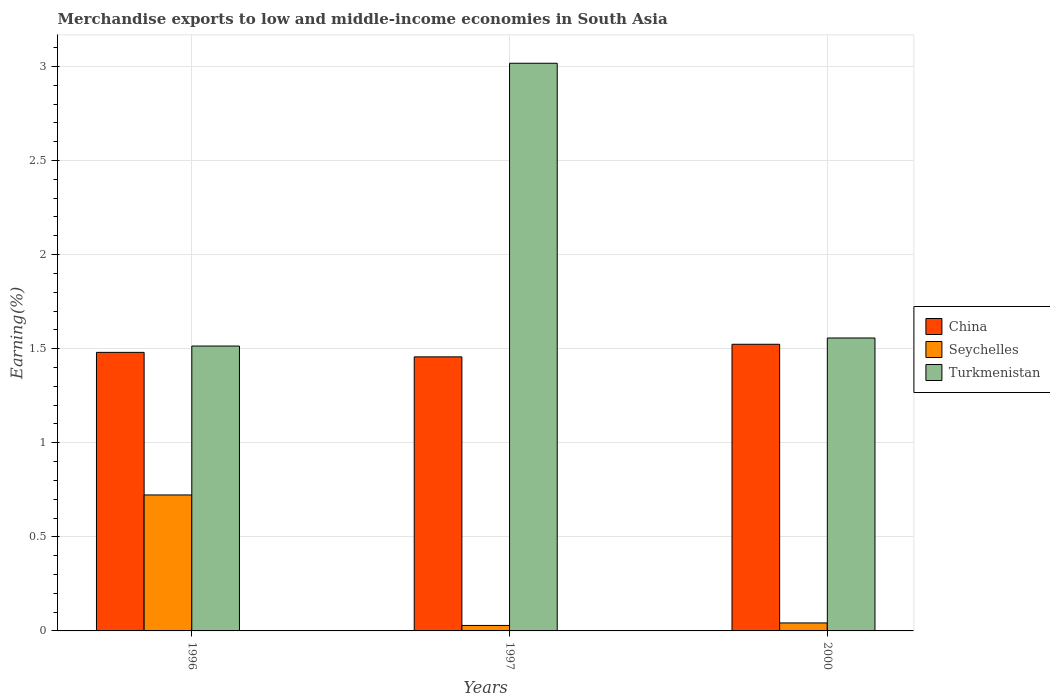Are the number of bars per tick equal to the number of legend labels?
Keep it short and to the point. Yes. How many bars are there on the 3rd tick from the right?
Offer a terse response. 3. What is the label of the 1st group of bars from the left?
Your response must be concise. 1996. In how many cases, is the number of bars for a given year not equal to the number of legend labels?
Ensure brevity in your answer.  0. What is the percentage of amount earned from merchandise exports in China in 1996?
Make the answer very short. 1.48. Across all years, what is the maximum percentage of amount earned from merchandise exports in Seychelles?
Offer a very short reply. 0.72. Across all years, what is the minimum percentage of amount earned from merchandise exports in Seychelles?
Provide a short and direct response. 0.03. In which year was the percentage of amount earned from merchandise exports in Seychelles maximum?
Offer a terse response. 1996. What is the total percentage of amount earned from merchandise exports in Seychelles in the graph?
Keep it short and to the point. 0.79. What is the difference between the percentage of amount earned from merchandise exports in Turkmenistan in 1996 and that in 2000?
Provide a short and direct response. -0.04. What is the difference between the percentage of amount earned from merchandise exports in Seychelles in 2000 and the percentage of amount earned from merchandise exports in Turkmenistan in 1997?
Keep it short and to the point. -2.97. What is the average percentage of amount earned from merchandise exports in China per year?
Give a very brief answer. 1.49. In the year 1996, what is the difference between the percentage of amount earned from merchandise exports in Turkmenistan and percentage of amount earned from merchandise exports in China?
Offer a terse response. 0.03. In how many years, is the percentage of amount earned from merchandise exports in Seychelles greater than 1.7 %?
Your answer should be compact. 0. What is the ratio of the percentage of amount earned from merchandise exports in China in 1997 to that in 2000?
Your answer should be very brief. 0.96. Is the percentage of amount earned from merchandise exports in China in 1996 less than that in 2000?
Give a very brief answer. Yes. What is the difference between the highest and the second highest percentage of amount earned from merchandise exports in China?
Give a very brief answer. 0.04. What is the difference between the highest and the lowest percentage of amount earned from merchandise exports in Turkmenistan?
Provide a succinct answer. 1.5. Is the sum of the percentage of amount earned from merchandise exports in Seychelles in 1996 and 2000 greater than the maximum percentage of amount earned from merchandise exports in Turkmenistan across all years?
Give a very brief answer. No. What does the 3rd bar from the right in 1997 represents?
Provide a short and direct response. China. Is it the case that in every year, the sum of the percentage of amount earned from merchandise exports in China and percentage of amount earned from merchandise exports in Turkmenistan is greater than the percentage of amount earned from merchandise exports in Seychelles?
Offer a very short reply. Yes. How many bars are there?
Provide a short and direct response. 9. How many years are there in the graph?
Provide a succinct answer. 3. Are the values on the major ticks of Y-axis written in scientific E-notation?
Your answer should be very brief. No. Does the graph contain any zero values?
Give a very brief answer. No. Does the graph contain grids?
Your answer should be very brief. Yes. How many legend labels are there?
Make the answer very short. 3. How are the legend labels stacked?
Your response must be concise. Vertical. What is the title of the graph?
Keep it short and to the point. Merchandise exports to low and middle-income economies in South Asia. What is the label or title of the X-axis?
Your response must be concise. Years. What is the label or title of the Y-axis?
Ensure brevity in your answer.  Earning(%). What is the Earning(%) in China in 1996?
Keep it short and to the point. 1.48. What is the Earning(%) in Seychelles in 1996?
Your response must be concise. 0.72. What is the Earning(%) in Turkmenistan in 1996?
Make the answer very short. 1.51. What is the Earning(%) of China in 1997?
Your response must be concise. 1.46. What is the Earning(%) in Seychelles in 1997?
Provide a succinct answer. 0.03. What is the Earning(%) of Turkmenistan in 1997?
Ensure brevity in your answer.  3.02. What is the Earning(%) in China in 2000?
Keep it short and to the point. 1.52. What is the Earning(%) of Seychelles in 2000?
Give a very brief answer. 0.04. What is the Earning(%) of Turkmenistan in 2000?
Offer a terse response. 1.56. Across all years, what is the maximum Earning(%) of China?
Make the answer very short. 1.52. Across all years, what is the maximum Earning(%) in Seychelles?
Offer a very short reply. 0.72. Across all years, what is the maximum Earning(%) of Turkmenistan?
Your response must be concise. 3.02. Across all years, what is the minimum Earning(%) in China?
Provide a short and direct response. 1.46. Across all years, what is the minimum Earning(%) of Seychelles?
Your answer should be compact. 0.03. Across all years, what is the minimum Earning(%) of Turkmenistan?
Your answer should be very brief. 1.51. What is the total Earning(%) of China in the graph?
Offer a very short reply. 4.46. What is the total Earning(%) of Seychelles in the graph?
Provide a succinct answer. 0.79. What is the total Earning(%) in Turkmenistan in the graph?
Make the answer very short. 6.09. What is the difference between the Earning(%) of China in 1996 and that in 1997?
Give a very brief answer. 0.02. What is the difference between the Earning(%) of Seychelles in 1996 and that in 1997?
Offer a very short reply. 0.69. What is the difference between the Earning(%) in Turkmenistan in 1996 and that in 1997?
Offer a very short reply. -1.5. What is the difference between the Earning(%) in China in 1996 and that in 2000?
Provide a succinct answer. -0.04. What is the difference between the Earning(%) in Seychelles in 1996 and that in 2000?
Give a very brief answer. 0.68. What is the difference between the Earning(%) in Turkmenistan in 1996 and that in 2000?
Offer a terse response. -0.04. What is the difference between the Earning(%) of China in 1997 and that in 2000?
Offer a terse response. -0.07. What is the difference between the Earning(%) in Seychelles in 1997 and that in 2000?
Provide a succinct answer. -0.01. What is the difference between the Earning(%) of Turkmenistan in 1997 and that in 2000?
Provide a succinct answer. 1.46. What is the difference between the Earning(%) of China in 1996 and the Earning(%) of Seychelles in 1997?
Provide a short and direct response. 1.45. What is the difference between the Earning(%) of China in 1996 and the Earning(%) of Turkmenistan in 1997?
Your response must be concise. -1.54. What is the difference between the Earning(%) of Seychelles in 1996 and the Earning(%) of Turkmenistan in 1997?
Your response must be concise. -2.29. What is the difference between the Earning(%) in China in 1996 and the Earning(%) in Seychelles in 2000?
Keep it short and to the point. 1.44. What is the difference between the Earning(%) in China in 1996 and the Earning(%) in Turkmenistan in 2000?
Make the answer very short. -0.08. What is the difference between the Earning(%) of Seychelles in 1996 and the Earning(%) of Turkmenistan in 2000?
Ensure brevity in your answer.  -0.83. What is the difference between the Earning(%) of China in 1997 and the Earning(%) of Seychelles in 2000?
Your response must be concise. 1.41. What is the difference between the Earning(%) of China in 1997 and the Earning(%) of Turkmenistan in 2000?
Keep it short and to the point. -0.1. What is the difference between the Earning(%) of Seychelles in 1997 and the Earning(%) of Turkmenistan in 2000?
Your response must be concise. -1.53. What is the average Earning(%) of China per year?
Keep it short and to the point. 1.49. What is the average Earning(%) of Seychelles per year?
Provide a succinct answer. 0.26. What is the average Earning(%) of Turkmenistan per year?
Offer a very short reply. 2.03. In the year 1996, what is the difference between the Earning(%) of China and Earning(%) of Seychelles?
Your answer should be very brief. 0.76. In the year 1996, what is the difference between the Earning(%) in China and Earning(%) in Turkmenistan?
Your answer should be very brief. -0.03. In the year 1996, what is the difference between the Earning(%) in Seychelles and Earning(%) in Turkmenistan?
Ensure brevity in your answer.  -0.79. In the year 1997, what is the difference between the Earning(%) of China and Earning(%) of Seychelles?
Your answer should be very brief. 1.43. In the year 1997, what is the difference between the Earning(%) of China and Earning(%) of Turkmenistan?
Your answer should be compact. -1.56. In the year 1997, what is the difference between the Earning(%) of Seychelles and Earning(%) of Turkmenistan?
Make the answer very short. -2.99. In the year 2000, what is the difference between the Earning(%) of China and Earning(%) of Seychelles?
Provide a short and direct response. 1.48. In the year 2000, what is the difference between the Earning(%) of China and Earning(%) of Turkmenistan?
Your answer should be very brief. -0.03. In the year 2000, what is the difference between the Earning(%) in Seychelles and Earning(%) in Turkmenistan?
Give a very brief answer. -1.51. What is the ratio of the Earning(%) of China in 1996 to that in 1997?
Your response must be concise. 1.02. What is the ratio of the Earning(%) of Seychelles in 1996 to that in 1997?
Keep it short and to the point. 24.85. What is the ratio of the Earning(%) in Turkmenistan in 1996 to that in 1997?
Your answer should be compact. 0.5. What is the ratio of the Earning(%) of China in 1996 to that in 2000?
Keep it short and to the point. 0.97. What is the ratio of the Earning(%) of Seychelles in 1996 to that in 2000?
Offer a terse response. 17.02. What is the ratio of the Earning(%) in Turkmenistan in 1996 to that in 2000?
Offer a terse response. 0.97. What is the ratio of the Earning(%) in China in 1997 to that in 2000?
Offer a terse response. 0.96. What is the ratio of the Earning(%) in Seychelles in 1997 to that in 2000?
Make the answer very short. 0.68. What is the ratio of the Earning(%) of Turkmenistan in 1997 to that in 2000?
Make the answer very short. 1.94. What is the difference between the highest and the second highest Earning(%) in China?
Provide a succinct answer. 0.04. What is the difference between the highest and the second highest Earning(%) of Seychelles?
Your answer should be compact. 0.68. What is the difference between the highest and the second highest Earning(%) of Turkmenistan?
Provide a short and direct response. 1.46. What is the difference between the highest and the lowest Earning(%) of China?
Give a very brief answer. 0.07. What is the difference between the highest and the lowest Earning(%) of Seychelles?
Keep it short and to the point. 0.69. What is the difference between the highest and the lowest Earning(%) of Turkmenistan?
Your answer should be compact. 1.5. 